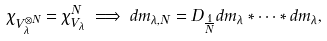<formula> <loc_0><loc_0><loc_500><loc_500>\chi _ { V _ { \lambda } ^ { \otimes N } } = \chi _ { V _ { \lambda } } ^ { N } \implies d m _ { \lambda , N } = D _ { \frac { 1 } { N } } d m _ { \lambda } * \cdots * d m _ { \lambda } ,</formula> 